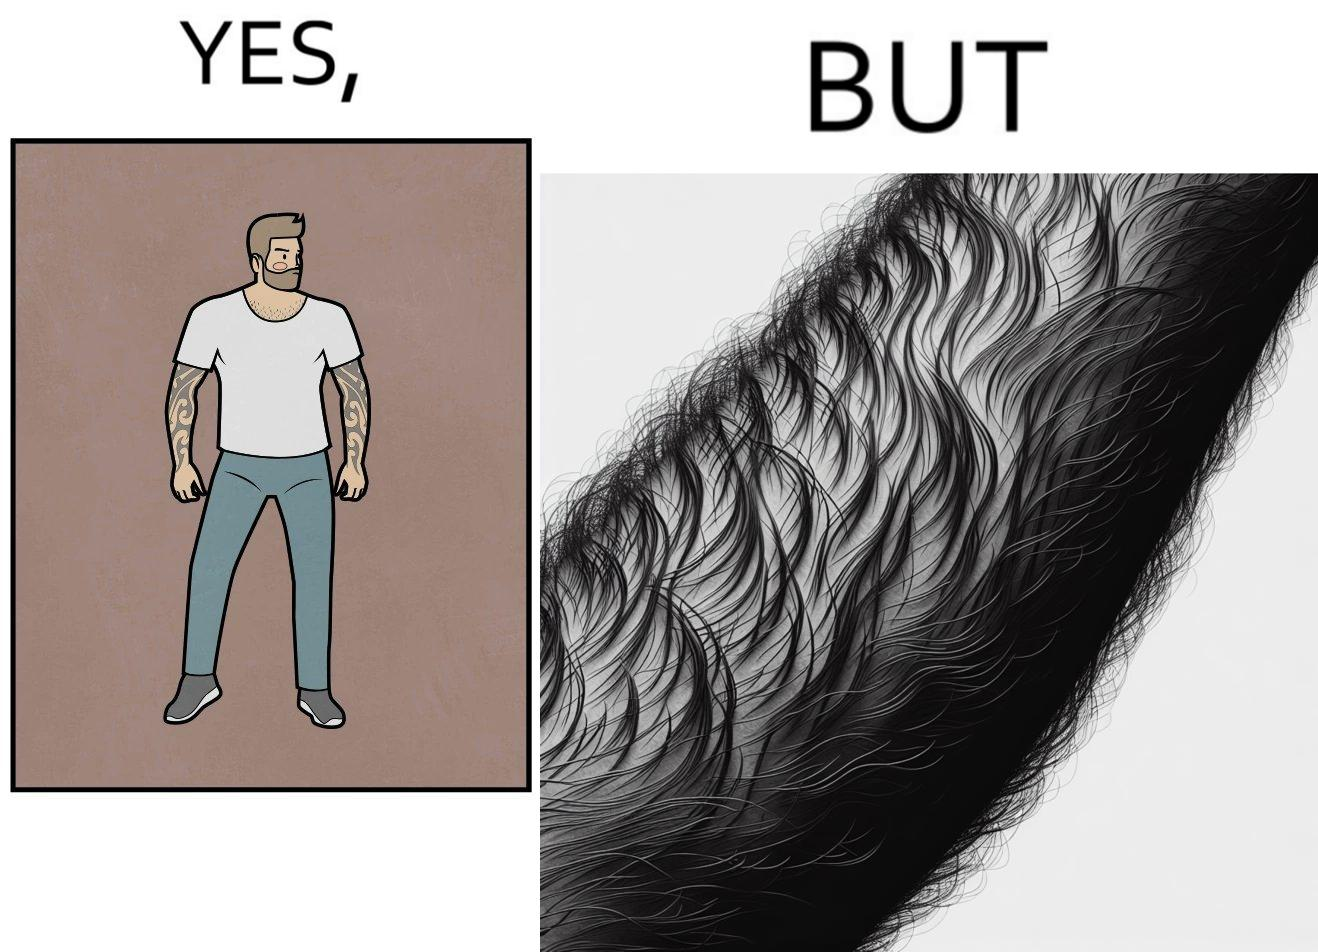Would you classify this image as satirical? Yes, this image is satirical. 